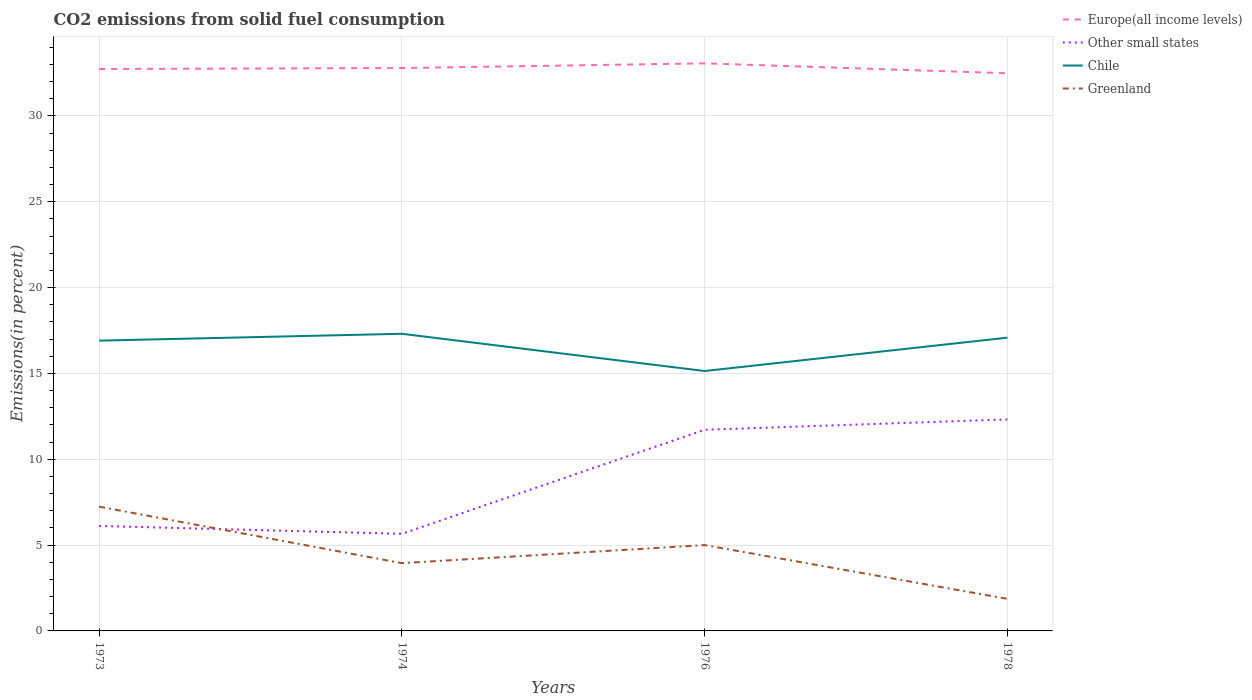How many different coloured lines are there?
Your answer should be compact. 4. Across all years, what is the maximum total CO2 emitted in Other small states?
Your response must be concise. 5.66. In which year was the total CO2 emitted in Europe(all income levels) maximum?
Provide a succinct answer. 1978. What is the total total CO2 emitted in Greenland in the graph?
Offer a terse response. 5.37. What is the difference between the highest and the second highest total CO2 emitted in Chile?
Your answer should be compact. 2.17. Is the total CO2 emitted in Other small states strictly greater than the total CO2 emitted in Chile over the years?
Your answer should be very brief. Yes. How many years are there in the graph?
Make the answer very short. 4. Does the graph contain any zero values?
Give a very brief answer. No. Does the graph contain grids?
Your answer should be very brief. Yes. Where does the legend appear in the graph?
Your answer should be very brief. Top right. How are the legend labels stacked?
Your answer should be very brief. Vertical. What is the title of the graph?
Keep it short and to the point. CO2 emissions from solid fuel consumption. Does "Equatorial Guinea" appear as one of the legend labels in the graph?
Your response must be concise. No. What is the label or title of the X-axis?
Your response must be concise. Years. What is the label or title of the Y-axis?
Provide a succinct answer. Emissions(in percent). What is the Emissions(in percent) of Europe(all income levels) in 1973?
Make the answer very short. 32.73. What is the Emissions(in percent) of Other small states in 1973?
Ensure brevity in your answer.  6.11. What is the Emissions(in percent) in Chile in 1973?
Offer a terse response. 16.91. What is the Emissions(in percent) in Greenland in 1973?
Offer a terse response. 7.24. What is the Emissions(in percent) in Europe(all income levels) in 1974?
Provide a succinct answer. 32.79. What is the Emissions(in percent) of Other small states in 1974?
Your response must be concise. 5.66. What is the Emissions(in percent) of Chile in 1974?
Offer a terse response. 17.31. What is the Emissions(in percent) in Greenland in 1974?
Your answer should be compact. 3.95. What is the Emissions(in percent) in Europe(all income levels) in 1976?
Provide a short and direct response. 33.06. What is the Emissions(in percent) in Other small states in 1976?
Offer a very short reply. 11.72. What is the Emissions(in percent) of Chile in 1976?
Keep it short and to the point. 15.14. What is the Emissions(in percent) in Europe(all income levels) in 1978?
Keep it short and to the point. 32.48. What is the Emissions(in percent) in Other small states in 1978?
Your response must be concise. 12.32. What is the Emissions(in percent) in Chile in 1978?
Ensure brevity in your answer.  17.08. What is the Emissions(in percent) in Greenland in 1978?
Give a very brief answer. 1.87. Across all years, what is the maximum Emissions(in percent) in Europe(all income levels)?
Your answer should be compact. 33.06. Across all years, what is the maximum Emissions(in percent) of Other small states?
Keep it short and to the point. 12.32. Across all years, what is the maximum Emissions(in percent) of Chile?
Offer a very short reply. 17.31. Across all years, what is the maximum Emissions(in percent) in Greenland?
Offer a very short reply. 7.24. Across all years, what is the minimum Emissions(in percent) of Europe(all income levels)?
Offer a very short reply. 32.48. Across all years, what is the minimum Emissions(in percent) in Other small states?
Provide a succinct answer. 5.66. Across all years, what is the minimum Emissions(in percent) of Chile?
Keep it short and to the point. 15.14. Across all years, what is the minimum Emissions(in percent) in Greenland?
Your answer should be compact. 1.87. What is the total Emissions(in percent) in Europe(all income levels) in the graph?
Your answer should be very brief. 131.05. What is the total Emissions(in percent) in Other small states in the graph?
Offer a terse response. 35.8. What is the total Emissions(in percent) of Chile in the graph?
Keep it short and to the point. 66.43. What is the total Emissions(in percent) in Greenland in the graph?
Give a very brief answer. 18.05. What is the difference between the Emissions(in percent) of Europe(all income levels) in 1973 and that in 1974?
Keep it short and to the point. -0.06. What is the difference between the Emissions(in percent) of Other small states in 1973 and that in 1974?
Provide a short and direct response. 0.46. What is the difference between the Emissions(in percent) in Chile in 1973 and that in 1974?
Offer a very short reply. -0.4. What is the difference between the Emissions(in percent) in Greenland in 1973 and that in 1974?
Your answer should be compact. 3.29. What is the difference between the Emissions(in percent) of Europe(all income levels) in 1973 and that in 1976?
Make the answer very short. -0.33. What is the difference between the Emissions(in percent) of Other small states in 1973 and that in 1976?
Provide a short and direct response. -5.6. What is the difference between the Emissions(in percent) in Chile in 1973 and that in 1976?
Provide a short and direct response. 1.77. What is the difference between the Emissions(in percent) of Greenland in 1973 and that in 1976?
Provide a short and direct response. 2.24. What is the difference between the Emissions(in percent) of Europe(all income levels) in 1973 and that in 1978?
Provide a short and direct response. 0.25. What is the difference between the Emissions(in percent) in Other small states in 1973 and that in 1978?
Offer a terse response. -6.2. What is the difference between the Emissions(in percent) in Chile in 1973 and that in 1978?
Make the answer very short. -0.17. What is the difference between the Emissions(in percent) in Greenland in 1973 and that in 1978?
Make the answer very short. 5.37. What is the difference between the Emissions(in percent) in Europe(all income levels) in 1974 and that in 1976?
Your response must be concise. -0.27. What is the difference between the Emissions(in percent) of Other small states in 1974 and that in 1976?
Your answer should be compact. -6.06. What is the difference between the Emissions(in percent) in Chile in 1974 and that in 1976?
Your response must be concise. 2.17. What is the difference between the Emissions(in percent) of Greenland in 1974 and that in 1976?
Your answer should be very brief. -1.05. What is the difference between the Emissions(in percent) in Europe(all income levels) in 1974 and that in 1978?
Give a very brief answer. 0.3. What is the difference between the Emissions(in percent) of Other small states in 1974 and that in 1978?
Your answer should be compact. -6.66. What is the difference between the Emissions(in percent) in Chile in 1974 and that in 1978?
Keep it short and to the point. 0.23. What is the difference between the Emissions(in percent) of Greenland in 1974 and that in 1978?
Make the answer very short. 2.08. What is the difference between the Emissions(in percent) of Europe(all income levels) in 1976 and that in 1978?
Keep it short and to the point. 0.58. What is the difference between the Emissions(in percent) in Other small states in 1976 and that in 1978?
Offer a terse response. -0.6. What is the difference between the Emissions(in percent) of Chile in 1976 and that in 1978?
Provide a succinct answer. -1.94. What is the difference between the Emissions(in percent) of Greenland in 1976 and that in 1978?
Offer a very short reply. 3.13. What is the difference between the Emissions(in percent) of Europe(all income levels) in 1973 and the Emissions(in percent) of Other small states in 1974?
Make the answer very short. 27.07. What is the difference between the Emissions(in percent) of Europe(all income levels) in 1973 and the Emissions(in percent) of Chile in 1974?
Your response must be concise. 15.42. What is the difference between the Emissions(in percent) in Europe(all income levels) in 1973 and the Emissions(in percent) in Greenland in 1974?
Give a very brief answer. 28.78. What is the difference between the Emissions(in percent) of Other small states in 1973 and the Emissions(in percent) of Chile in 1974?
Provide a short and direct response. -11.19. What is the difference between the Emissions(in percent) of Other small states in 1973 and the Emissions(in percent) of Greenland in 1974?
Provide a succinct answer. 2.17. What is the difference between the Emissions(in percent) in Chile in 1973 and the Emissions(in percent) in Greenland in 1974?
Keep it short and to the point. 12.96. What is the difference between the Emissions(in percent) in Europe(all income levels) in 1973 and the Emissions(in percent) in Other small states in 1976?
Your answer should be compact. 21.01. What is the difference between the Emissions(in percent) of Europe(all income levels) in 1973 and the Emissions(in percent) of Chile in 1976?
Make the answer very short. 17.59. What is the difference between the Emissions(in percent) in Europe(all income levels) in 1973 and the Emissions(in percent) in Greenland in 1976?
Provide a succinct answer. 27.73. What is the difference between the Emissions(in percent) in Other small states in 1973 and the Emissions(in percent) in Chile in 1976?
Provide a succinct answer. -9.02. What is the difference between the Emissions(in percent) in Other small states in 1973 and the Emissions(in percent) in Greenland in 1976?
Make the answer very short. 1.11. What is the difference between the Emissions(in percent) of Chile in 1973 and the Emissions(in percent) of Greenland in 1976?
Your answer should be compact. 11.91. What is the difference between the Emissions(in percent) in Europe(all income levels) in 1973 and the Emissions(in percent) in Other small states in 1978?
Your answer should be very brief. 20.41. What is the difference between the Emissions(in percent) of Europe(all income levels) in 1973 and the Emissions(in percent) of Chile in 1978?
Provide a short and direct response. 15.65. What is the difference between the Emissions(in percent) in Europe(all income levels) in 1973 and the Emissions(in percent) in Greenland in 1978?
Ensure brevity in your answer.  30.86. What is the difference between the Emissions(in percent) in Other small states in 1973 and the Emissions(in percent) in Chile in 1978?
Provide a succinct answer. -10.97. What is the difference between the Emissions(in percent) in Other small states in 1973 and the Emissions(in percent) in Greenland in 1978?
Provide a short and direct response. 4.25. What is the difference between the Emissions(in percent) in Chile in 1973 and the Emissions(in percent) in Greenland in 1978?
Offer a very short reply. 15.04. What is the difference between the Emissions(in percent) in Europe(all income levels) in 1974 and the Emissions(in percent) in Other small states in 1976?
Offer a terse response. 21.07. What is the difference between the Emissions(in percent) of Europe(all income levels) in 1974 and the Emissions(in percent) of Chile in 1976?
Provide a succinct answer. 17.65. What is the difference between the Emissions(in percent) in Europe(all income levels) in 1974 and the Emissions(in percent) in Greenland in 1976?
Offer a terse response. 27.79. What is the difference between the Emissions(in percent) in Other small states in 1974 and the Emissions(in percent) in Chile in 1976?
Keep it short and to the point. -9.48. What is the difference between the Emissions(in percent) of Other small states in 1974 and the Emissions(in percent) of Greenland in 1976?
Provide a short and direct response. 0.66. What is the difference between the Emissions(in percent) of Chile in 1974 and the Emissions(in percent) of Greenland in 1976?
Provide a succinct answer. 12.31. What is the difference between the Emissions(in percent) of Europe(all income levels) in 1974 and the Emissions(in percent) of Other small states in 1978?
Give a very brief answer. 20.47. What is the difference between the Emissions(in percent) in Europe(all income levels) in 1974 and the Emissions(in percent) in Chile in 1978?
Your answer should be compact. 15.7. What is the difference between the Emissions(in percent) of Europe(all income levels) in 1974 and the Emissions(in percent) of Greenland in 1978?
Offer a very short reply. 30.92. What is the difference between the Emissions(in percent) of Other small states in 1974 and the Emissions(in percent) of Chile in 1978?
Provide a succinct answer. -11.43. What is the difference between the Emissions(in percent) in Other small states in 1974 and the Emissions(in percent) in Greenland in 1978?
Your answer should be very brief. 3.79. What is the difference between the Emissions(in percent) in Chile in 1974 and the Emissions(in percent) in Greenland in 1978?
Offer a terse response. 15.44. What is the difference between the Emissions(in percent) of Europe(all income levels) in 1976 and the Emissions(in percent) of Other small states in 1978?
Your response must be concise. 20.74. What is the difference between the Emissions(in percent) of Europe(all income levels) in 1976 and the Emissions(in percent) of Chile in 1978?
Make the answer very short. 15.98. What is the difference between the Emissions(in percent) in Europe(all income levels) in 1976 and the Emissions(in percent) in Greenland in 1978?
Keep it short and to the point. 31.19. What is the difference between the Emissions(in percent) of Other small states in 1976 and the Emissions(in percent) of Chile in 1978?
Provide a succinct answer. -5.37. What is the difference between the Emissions(in percent) in Other small states in 1976 and the Emissions(in percent) in Greenland in 1978?
Ensure brevity in your answer.  9.85. What is the difference between the Emissions(in percent) of Chile in 1976 and the Emissions(in percent) of Greenland in 1978?
Offer a terse response. 13.27. What is the average Emissions(in percent) in Europe(all income levels) per year?
Your answer should be very brief. 32.76. What is the average Emissions(in percent) in Other small states per year?
Your response must be concise. 8.95. What is the average Emissions(in percent) of Chile per year?
Your answer should be compact. 16.61. What is the average Emissions(in percent) in Greenland per year?
Give a very brief answer. 4.51. In the year 1973, what is the difference between the Emissions(in percent) of Europe(all income levels) and Emissions(in percent) of Other small states?
Offer a very short reply. 26.61. In the year 1973, what is the difference between the Emissions(in percent) of Europe(all income levels) and Emissions(in percent) of Chile?
Offer a terse response. 15.82. In the year 1973, what is the difference between the Emissions(in percent) in Europe(all income levels) and Emissions(in percent) in Greenland?
Keep it short and to the point. 25.49. In the year 1973, what is the difference between the Emissions(in percent) in Other small states and Emissions(in percent) in Chile?
Your answer should be compact. -10.79. In the year 1973, what is the difference between the Emissions(in percent) in Other small states and Emissions(in percent) in Greenland?
Ensure brevity in your answer.  -1.12. In the year 1973, what is the difference between the Emissions(in percent) of Chile and Emissions(in percent) of Greenland?
Offer a very short reply. 9.67. In the year 1974, what is the difference between the Emissions(in percent) of Europe(all income levels) and Emissions(in percent) of Other small states?
Make the answer very short. 27.13. In the year 1974, what is the difference between the Emissions(in percent) of Europe(all income levels) and Emissions(in percent) of Chile?
Ensure brevity in your answer.  15.48. In the year 1974, what is the difference between the Emissions(in percent) in Europe(all income levels) and Emissions(in percent) in Greenland?
Make the answer very short. 28.84. In the year 1974, what is the difference between the Emissions(in percent) of Other small states and Emissions(in percent) of Chile?
Offer a very short reply. -11.65. In the year 1974, what is the difference between the Emissions(in percent) of Other small states and Emissions(in percent) of Greenland?
Give a very brief answer. 1.71. In the year 1974, what is the difference between the Emissions(in percent) in Chile and Emissions(in percent) in Greenland?
Provide a short and direct response. 13.36. In the year 1976, what is the difference between the Emissions(in percent) of Europe(all income levels) and Emissions(in percent) of Other small states?
Offer a very short reply. 21.34. In the year 1976, what is the difference between the Emissions(in percent) of Europe(all income levels) and Emissions(in percent) of Chile?
Your answer should be very brief. 17.92. In the year 1976, what is the difference between the Emissions(in percent) of Europe(all income levels) and Emissions(in percent) of Greenland?
Your response must be concise. 28.06. In the year 1976, what is the difference between the Emissions(in percent) in Other small states and Emissions(in percent) in Chile?
Keep it short and to the point. -3.42. In the year 1976, what is the difference between the Emissions(in percent) of Other small states and Emissions(in percent) of Greenland?
Offer a very short reply. 6.72. In the year 1976, what is the difference between the Emissions(in percent) in Chile and Emissions(in percent) in Greenland?
Make the answer very short. 10.14. In the year 1978, what is the difference between the Emissions(in percent) of Europe(all income levels) and Emissions(in percent) of Other small states?
Provide a succinct answer. 20.16. In the year 1978, what is the difference between the Emissions(in percent) in Europe(all income levels) and Emissions(in percent) in Chile?
Keep it short and to the point. 15.4. In the year 1978, what is the difference between the Emissions(in percent) in Europe(all income levels) and Emissions(in percent) in Greenland?
Your answer should be compact. 30.61. In the year 1978, what is the difference between the Emissions(in percent) of Other small states and Emissions(in percent) of Chile?
Keep it short and to the point. -4.76. In the year 1978, what is the difference between the Emissions(in percent) of Other small states and Emissions(in percent) of Greenland?
Your answer should be very brief. 10.45. In the year 1978, what is the difference between the Emissions(in percent) of Chile and Emissions(in percent) of Greenland?
Keep it short and to the point. 15.21. What is the ratio of the Emissions(in percent) in Europe(all income levels) in 1973 to that in 1974?
Give a very brief answer. 1. What is the ratio of the Emissions(in percent) in Other small states in 1973 to that in 1974?
Keep it short and to the point. 1.08. What is the ratio of the Emissions(in percent) in Chile in 1973 to that in 1974?
Keep it short and to the point. 0.98. What is the ratio of the Emissions(in percent) of Greenland in 1973 to that in 1974?
Your response must be concise. 1.83. What is the ratio of the Emissions(in percent) in Europe(all income levels) in 1973 to that in 1976?
Your response must be concise. 0.99. What is the ratio of the Emissions(in percent) in Other small states in 1973 to that in 1976?
Provide a succinct answer. 0.52. What is the ratio of the Emissions(in percent) of Chile in 1973 to that in 1976?
Your answer should be very brief. 1.12. What is the ratio of the Emissions(in percent) of Greenland in 1973 to that in 1976?
Make the answer very short. 1.45. What is the ratio of the Emissions(in percent) in Europe(all income levels) in 1973 to that in 1978?
Your response must be concise. 1.01. What is the ratio of the Emissions(in percent) of Other small states in 1973 to that in 1978?
Provide a succinct answer. 0.5. What is the ratio of the Emissions(in percent) of Chile in 1973 to that in 1978?
Make the answer very short. 0.99. What is the ratio of the Emissions(in percent) in Greenland in 1973 to that in 1978?
Offer a very short reply. 3.87. What is the ratio of the Emissions(in percent) in Other small states in 1974 to that in 1976?
Provide a succinct answer. 0.48. What is the ratio of the Emissions(in percent) in Chile in 1974 to that in 1976?
Offer a very short reply. 1.14. What is the ratio of the Emissions(in percent) of Greenland in 1974 to that in 1976?
Your answer should be compact. 0.79. What is the ratio of the Emissions(in percent) of Europe(all income levels) in 1974 to that in 1978?
Your response must be concise. 1.01. What is the ratio of the Emissions(in percent) of Other small states in 1974 to that in 1978?
Make the answer very short. 0.46. What is the ratio of the Emissions(in percent) in Chile in 1974 to that in 1978?
Keep it short and to the point. 1.01. What is the ratio of the Emissions(in percent) of Greenland in 1974 to that in 1978?
Offer a terse response. 2.11. What is the ratio of the Emissions(in percent) in Europe(all income levels) in 1976 to that in 1978?
Ensure brevity in your answer.  1.02. What is the ratio of the Emissions(in percent) in Other small states in 1976 to that in 1978?
Your answer should be compact. 0.95. What is the ratio of the Emissions(in percent) in Chile in 1976 to that in 1978?
Your answer should be very brief. 0.89. What is the ratio of the Emissions(in percent) of Greenland in 1976 to that in 1978?
Offer a terse response. 2.67. What is the difference between the highest and the second highest Emissions(in percent) in Europe(all income levels)?
Ensure brevity in your answer.  0.27. What is the difference between the highest and the second highest Emissions(in percent) of Other small states?
Provide a short and direct response. 0.6. What is the difference between the highest and the second highest Emissions(in percent) in Chile?
Your answer should be compact. 0.23. What is the difference between the highest and the second highest Emissions(in percent) of Greenland?
Provide a short and direct response. 2.24. What is the difference between the highest and the lowest Emissions(in percent) of Europe(all income levels)?
Your response must be concise. 0.58. What is the difference between the highest and the lowest Emissions(in percent) in Other small states?
Your answer should be very brief. 6.66. What is the difference between the highest and the lowest Emissions(in percent) in Chile?
Ensure brevity in your answer.  2.17. What is the difference between the highest and the lowest Emissions(in percent) of Greenland?
Provide a short and direct response. 5.37. 